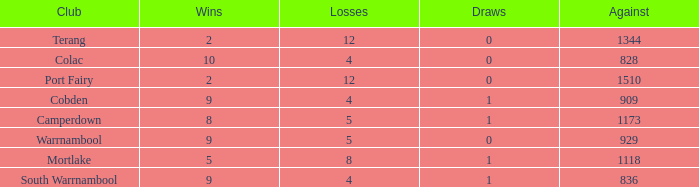What is the sum of losses for Against values over 1510? None. 